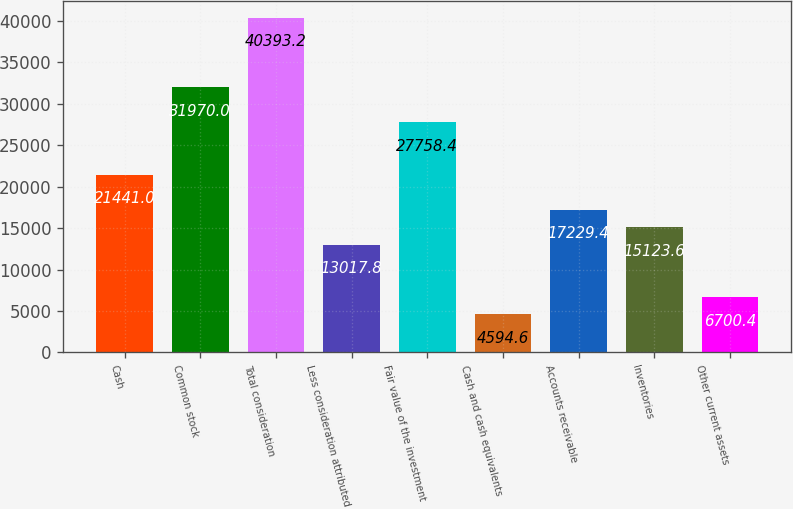Convert chart. <chart><loc_0><loc_0><loc_500><loc_500><bar_chart><fcel>Cash<fcel>Common stock<fcel>Total consideration<fcel>Less consideration attributed<fcel>Fair value of the investment<fcel>Cash and cash equivalents<fcel>Accounts receivable<fcel>Inventories<fcel>Other current assets<nl><fcel>21441<fcel>31970<fcel>40393.2<fcel>13017.8<fcel>27758.4<fcel>4594.6<fcel>17229.4<fcel>15123.6<fcel>6700.4<nl></chart> 